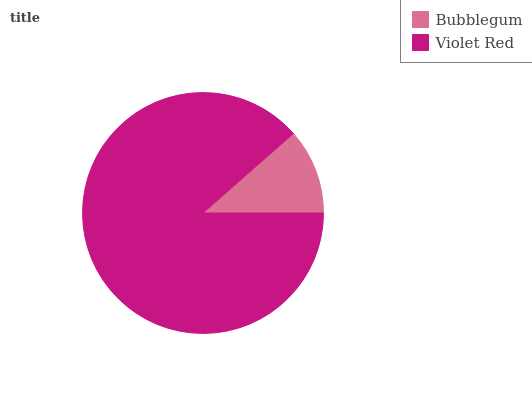Is Bubblegum the minimum?
Answer yes or no. Yes. Is Violet Red the maximum?
Answer yes or no. Yes. Is Violet Red the minimum?
Answer yes or no. No. Is Violet Red greater than Bubblegum?
Answer yes or no. Yes. Is Bubblegum less than Violet Red?
Answer yes or no. Yes. Is Bubblegum greater than Violet Red?
Answer yes or no. No. Is Violet Red less than Bubblegum?
Answer yes or no. No. Is Violet Red the high median?
Answer yes or no. Yes. Is Bubblegum the low median?
Answer yes or no. Yes. Is Bubblegum the high median?
Answer yes or no. No. Is Violet Red the low median?
Answer yes or no. No. 